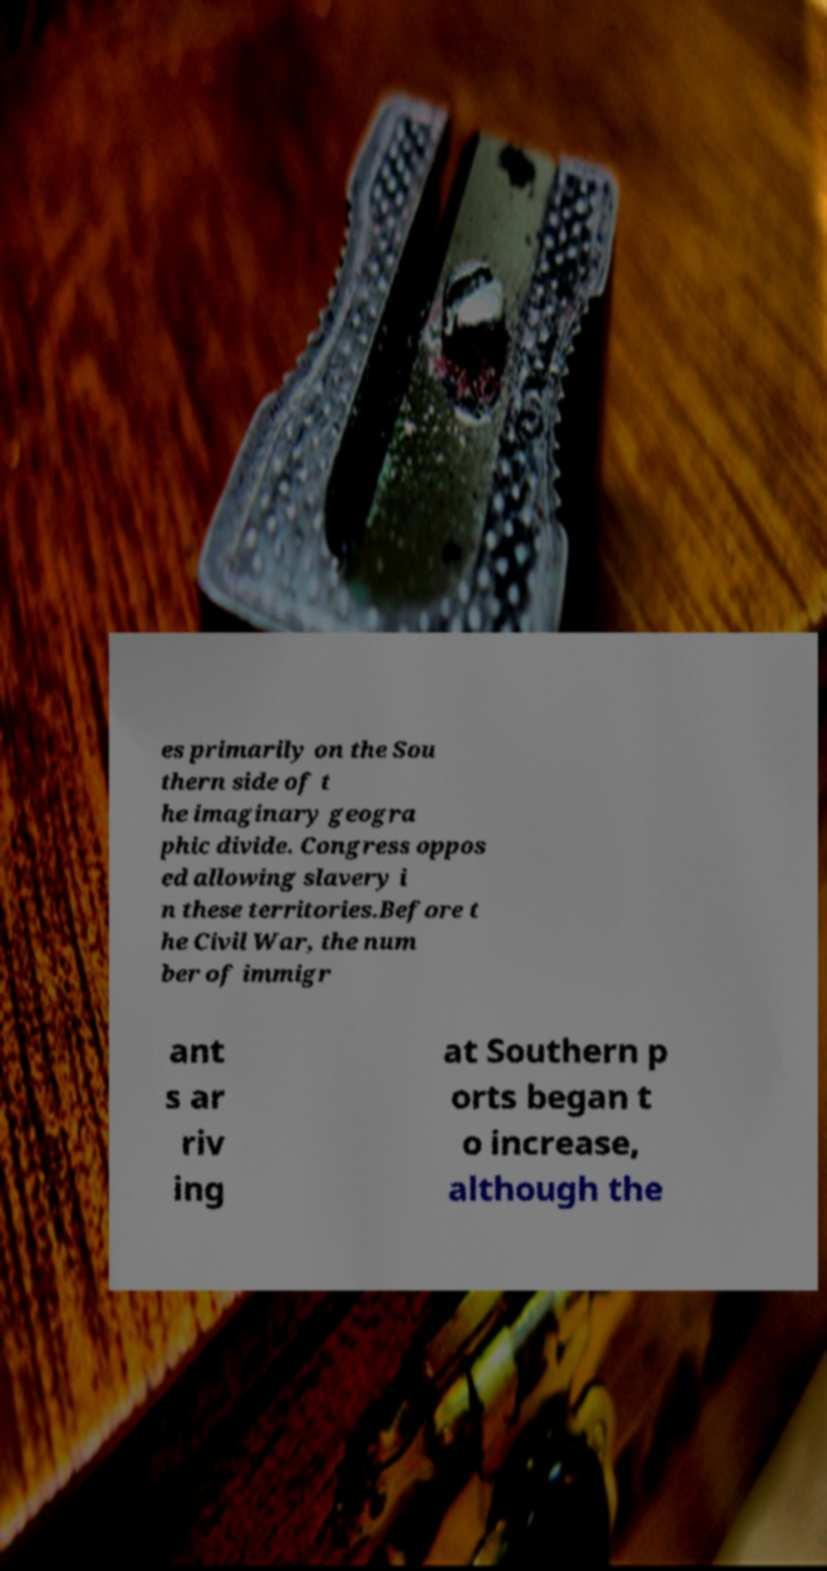Can you accurately transcribe the text from the provided image for me? es primarily on the Sou thern side of t he imaginary geogra phic divide. Congress oppos ed allowing slavery i n these territories.Before t he Civil War, the num ber of immigr ant s ar riv ing at Southern p orts began t o increase, although the 